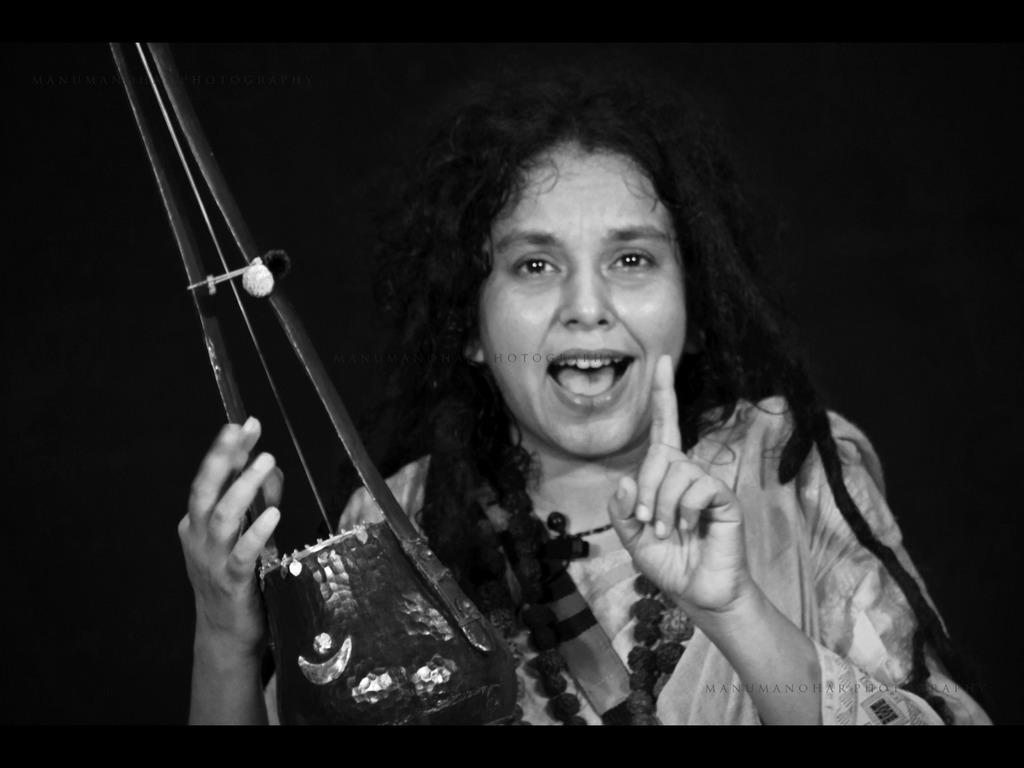Can you describe this image briefly? In this picture there a lady in the center of the image, by holding a musical instrument in her hand. 